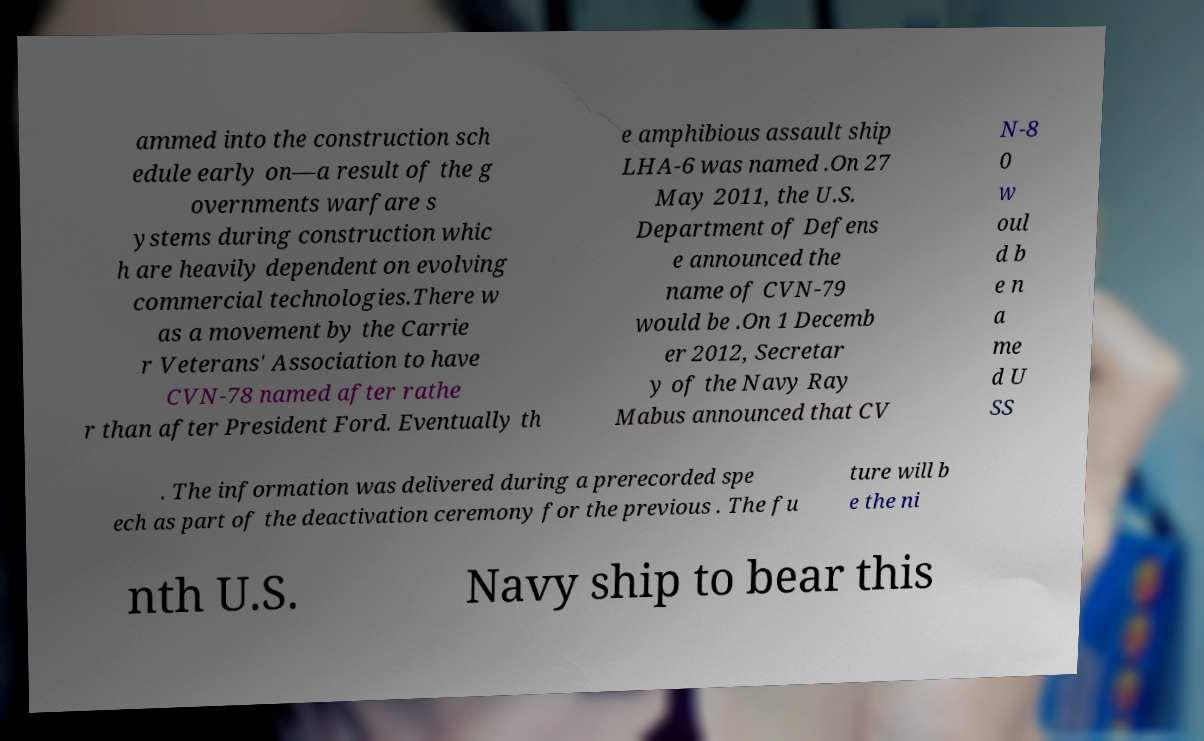Could you assist in decoding the text presented in this image and type it out clearly? ammed into the construction sch edule early on—a result of the g overnments warfare s ystems during construction whic h are heavily dependent on evolving commercial technologies.There w as a movement by the Carrie r Veterans' Association to have CVN-78 named after rathe r than after President Ford. Eventually th e amphibious assault ship LHA-6 was named .On 27 May 2011, the U.S. Department of Defens e announced the name of CVN-79 would be .On 1 Decemb er 2012, Secretar y of the Navy Ray Mabus announced that CV N-8 0 w oul d b e n a me d U SS . The information was delivered during a prerecorded spe ech as part of the deactivation ceremony for the previous . The fu ture will b e the ni nth U.S. Navy ship to bear this 